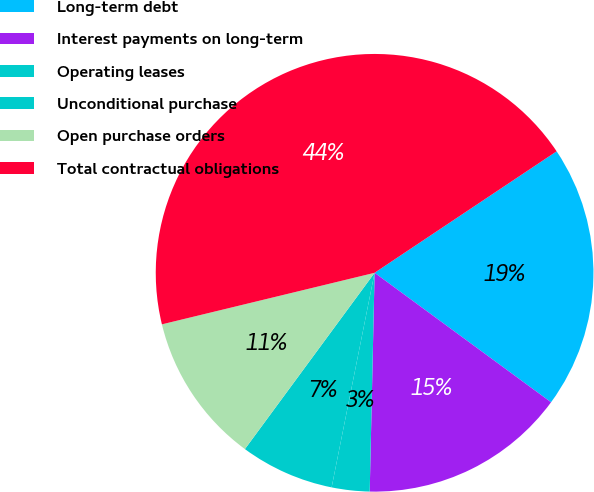Convert chart. <chart><loc_0><loc_0><loc_500><loc_500><pie_chart><fcel>Long-term debt<fcel>Interest payments on long-term<fcel>Operating leases<fcel>Unconditional purchase<fcel>Open purchase orders<fcel>Total contractual obligations<nl><fcel>19.44%<fcel>15.28%<fcel>2.79%<fcel>6.95%<fcel>11.12%<fcel>44.42%<nl></chart> 